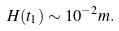Convert formula to latex. <formula><loc_0><loc_0><loc_500><loc_500>H ( t _ { 1 } ) \sim 1 0 ^ { - 2 } m .</formula> 